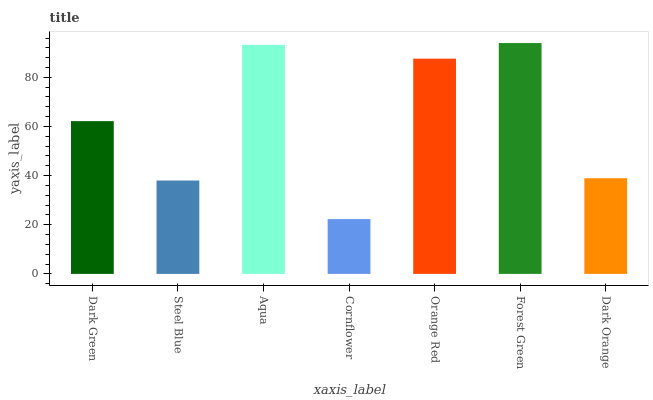Is Cornflower the minimum?
Answer yes or no. Yes. Is Forest Green the maximum?
Answer yes or no. Yes. Is Steel Blue the minimum?
Answer yes or no. No. Is Steel Blue the maximum?
Answer yes or no. No. Is Dark Green greater than Steel Blue?
Answer yes or no. Yes. Is Steel Blue less than Dark Green?
Answer yes or no. Yes. Is Steel Blue greater than Dark Green?
Answer yes or no. No. Is Dark Green less than Steel Blue?
Answer yes or no. No. Is Dark Green the high median?
Answer yes or no. Yes. Is Dark Green the low median?
Answer yes or no. Yes. Is Aqua the high median?
Answer yes or no. No. Is Steel Blue the low median?
Answer yes or no. No. 